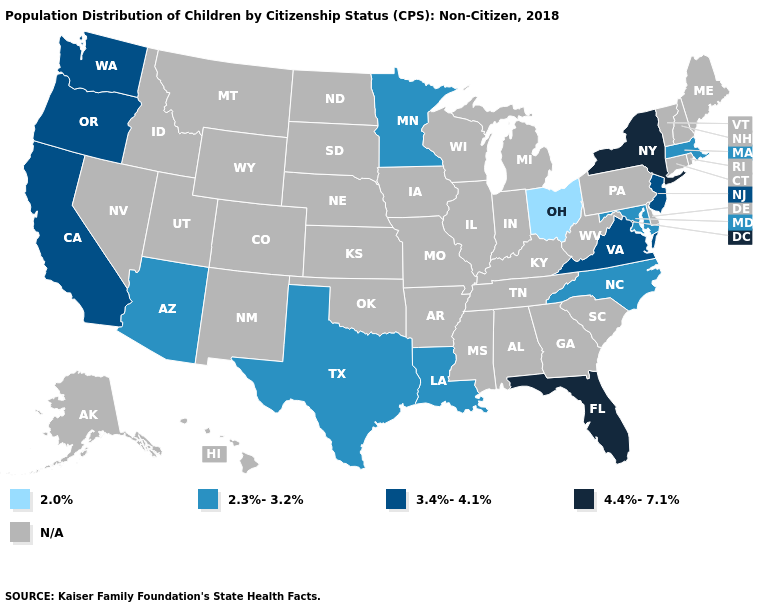Name the states that have a value in the range 2.0%?
Quick response, please. Ohio. Is the legend a continuous bar?
Concise answer only. No. Among the states that border New Mexico , which have the lowest value?
Be succinct. Arizona, Texas. What is the highest value in the West ?
Keep it brief. 3.4%-4.1%. Name the states that have a value in the range 2.0%?
Be succinct. Ohio. Does California have the highest value in the West?
Answer briefly. Yes. What is the value of Indiana?
Short answer required. N/A. What is the highest value in the USA?
Keep it brief. 4.4%-7.1%. How many symbols are there in the legend?
Quick response, please. 5. Name the states that have a value in the range 4.4%-7.1%?
Give a very brief answer. Florida, New York. Name the states that have a value in the range 2.0%?
Short answer required. Ohio. Name the states that have a value in the range 2.3%-3.2%?
Write a very short answer. Arizona, Louisiana, Maryland, Massachusetts, Minnesota, North Carolina, Texas. 